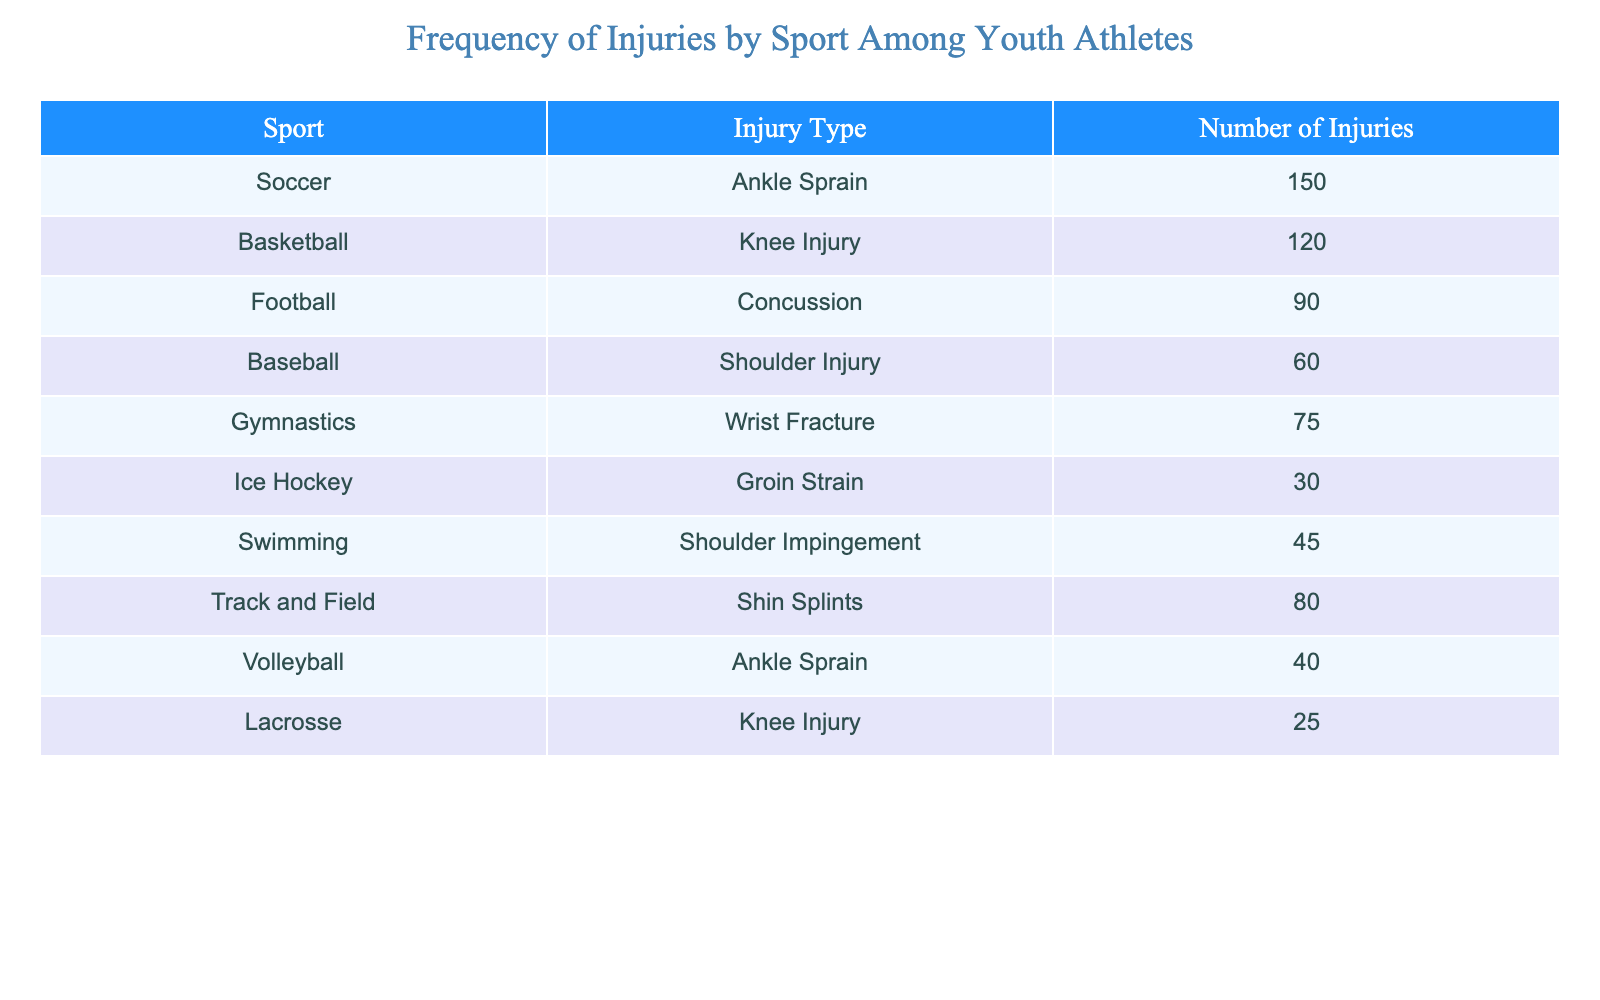What is the highest number of injuries recorded in a single sport? From the table, we can look at the "Number of Injuries" column and identify the maximum value. The highest number is 150, which corresponds to "Soccer".
Answer: 150 What sport had the second highest number of injuries? By examining the table, the sport with the highest number is "Soccer" with 150 injuries, followed by "Basketball" with 120 injuries.
Answer: Basketball How many total injuries were reported across all sports? To find the total, we need to sum the number of injuries for each sport: 150 + 120 + 90 + 60 + 75 + 30 + 45 + 80 + 40 + 25 = 705.
Answer: 705 Is it true that "Football" injuries are less than "Baseball" injuries? Comparing the number of injuries, "Football" had 90 injuries and "Baseball" had 60 injuries. Since 90 is greater than 60, the statement is false.
Answer: No What percentage of the total injuries does "Ankle Sprain" represent? First, we identify the number of "Ankle Sprain" injuries, which is 150 (from Soccer) and 40 (from Volleyball) for a total of 190. To find the percentage: (190/705) * 100 = 26.98%.
Answer: 27% Which injury type is the least reported? By reviewing the "Number of Injuries" column, we see that "Lacrosse" had the lowest number of injuries at 25.
Answer: Lacrosse What is the difference in the number of injuries between "Basketball" and "Ice Hockey"? "Basketball" had 120 injuries, while "Ice Hockey" had 30 injuries. The difference is 120 - 30 = 90.
Answer: 90 Which sports had injuries numbering more than 70? Looking at the table, the sports with more than 70 injuries are "Soccer" (150), "Basketball" (120), "Football" (90), "Gymnastics" (75), and "Track and Field" (80).
Answer: Soccer, Basketball, Football, Gymnastics, Track and Field On average, how many injuries occurred in "Swimming" and "Ice Hockey"? The number of injuries in "Swimming" is 45 and in "Ice Hockey" is 30. The average would be (45 + 30) / 2 = 37.5.
Answer: 37.5 